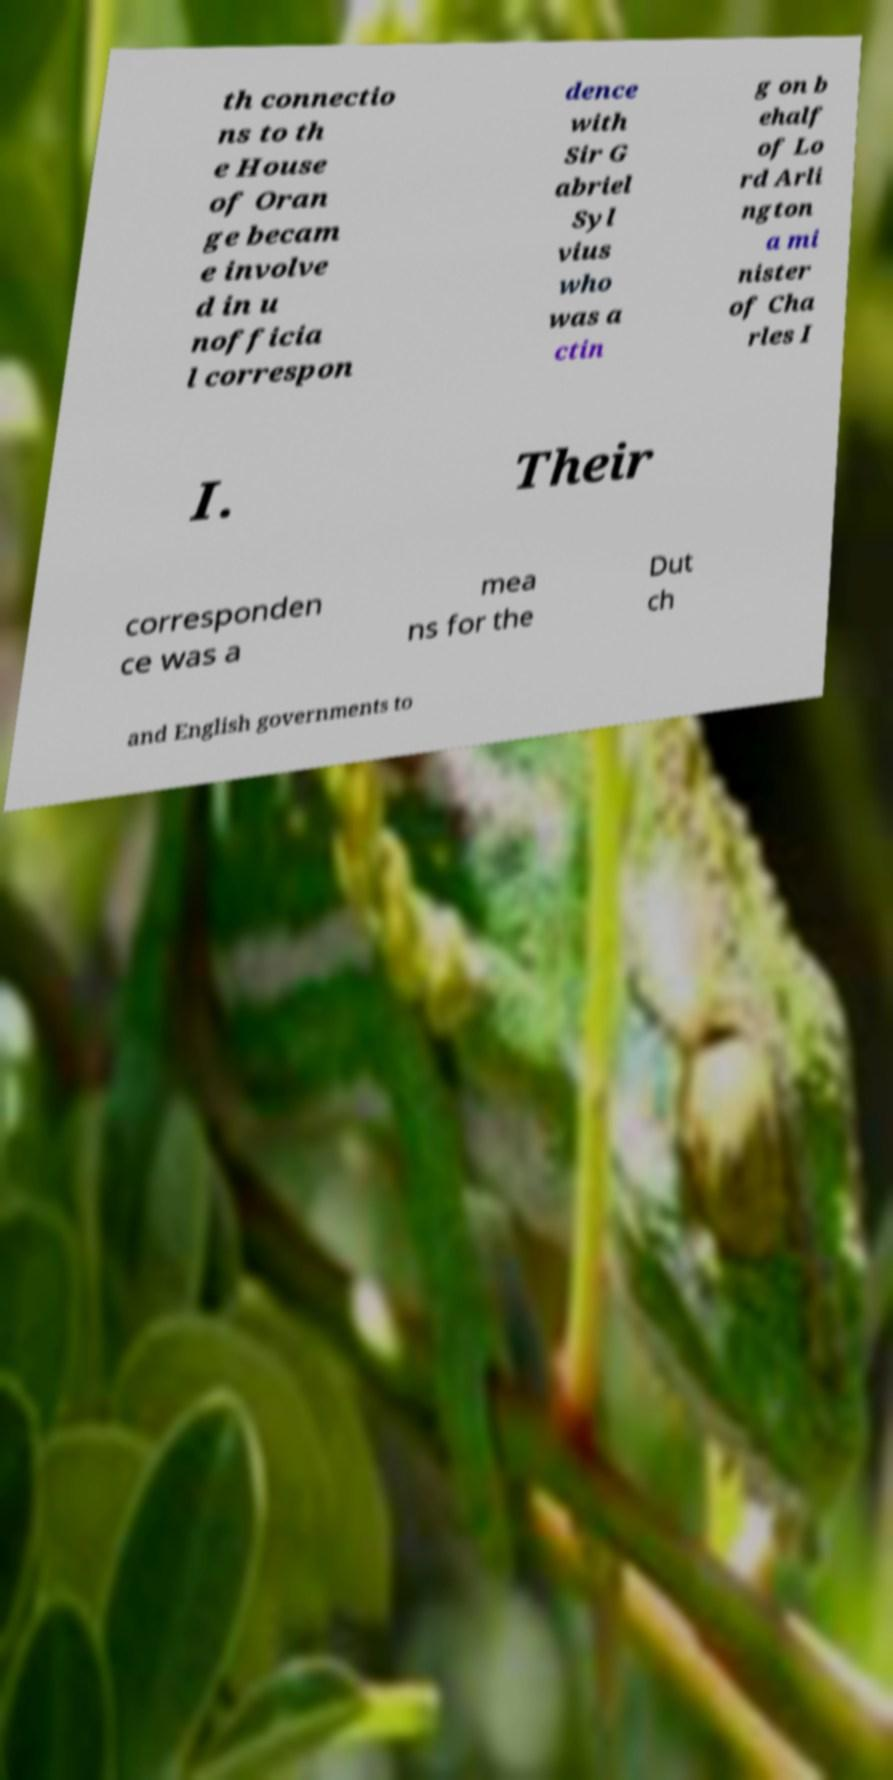Can you accurately transcribe the text from the provided image for me? th connectio ns to th e House of Oran ge becam e involve d in u nofficia l correspon dence with Sir G abriel Syl vius who was a ctin g on b ehalf of Lo rd Arli ngton a mi nister of Cha rles I I. Their corresponden ce was a mea ns for the Dut ch and English governments to 